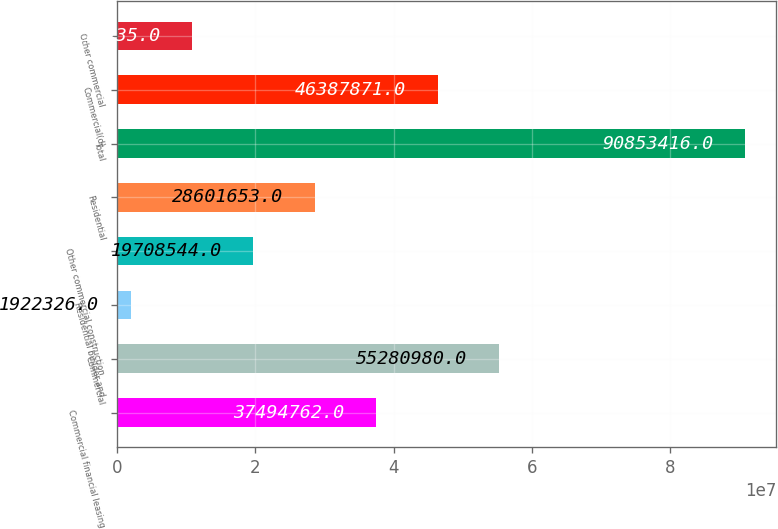<chart> <loc_0><loc_0><loc_500><loc_500><bar_chart><fcel>Commercial financial leasing<fcel>Commercial<fcel>Residential builder and<fcel>Other commercial construction<fcel>Residential<fcel>Total<fcel>Commercial(d)<fcel>Other commercial<nl><fcel>3.74948e+07<fcel>5.5281e+07<fcel>1.92233e+06<fcel>1.97085e+07<fcel>2.86017e+07<fcel>9.08534e+07<fcel>4.63879e+07<fcel>1.08154e+07<nl></chart> 